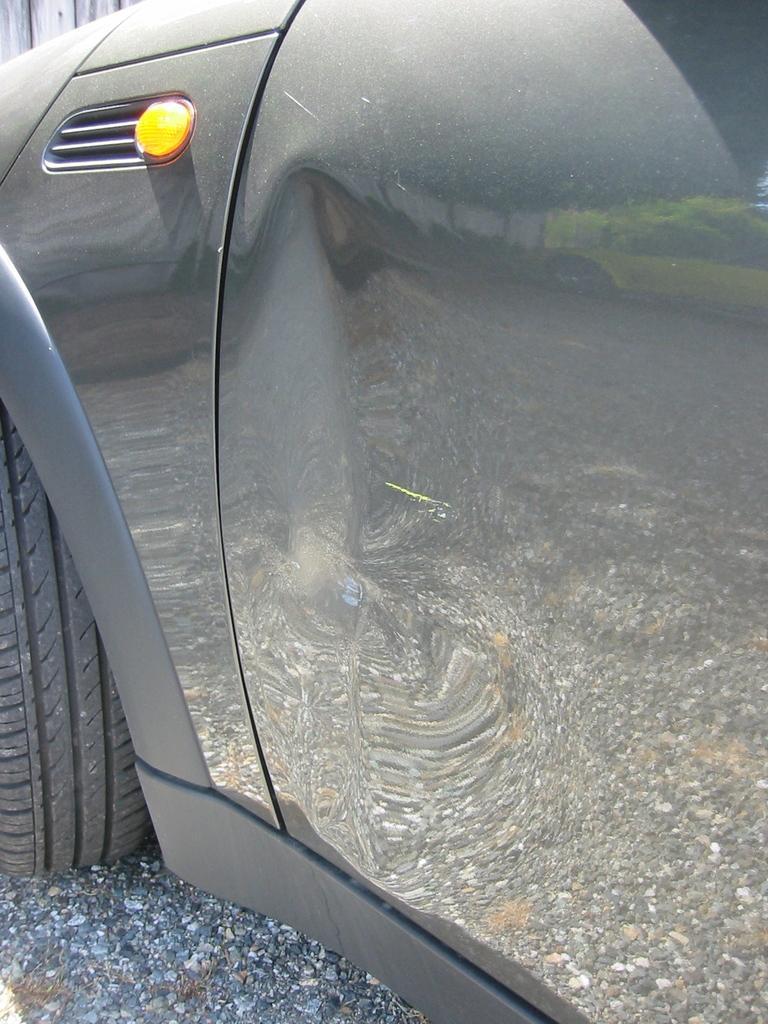Can you describe this image briefly? In this image we can see a car. At the bottom there is a road. 